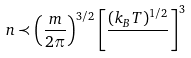Convert formula to latex. <formula><loc_0><loc_0><loc_500><loc_500>n \prec \left ( \frac { m } { 2 \pi } \right ) ^ { 3 / 2 } \left [ \frac { ( k _ { B } T ) ^ { 1 / 2 } } { } \right ] ^ { 3 }</formula> 